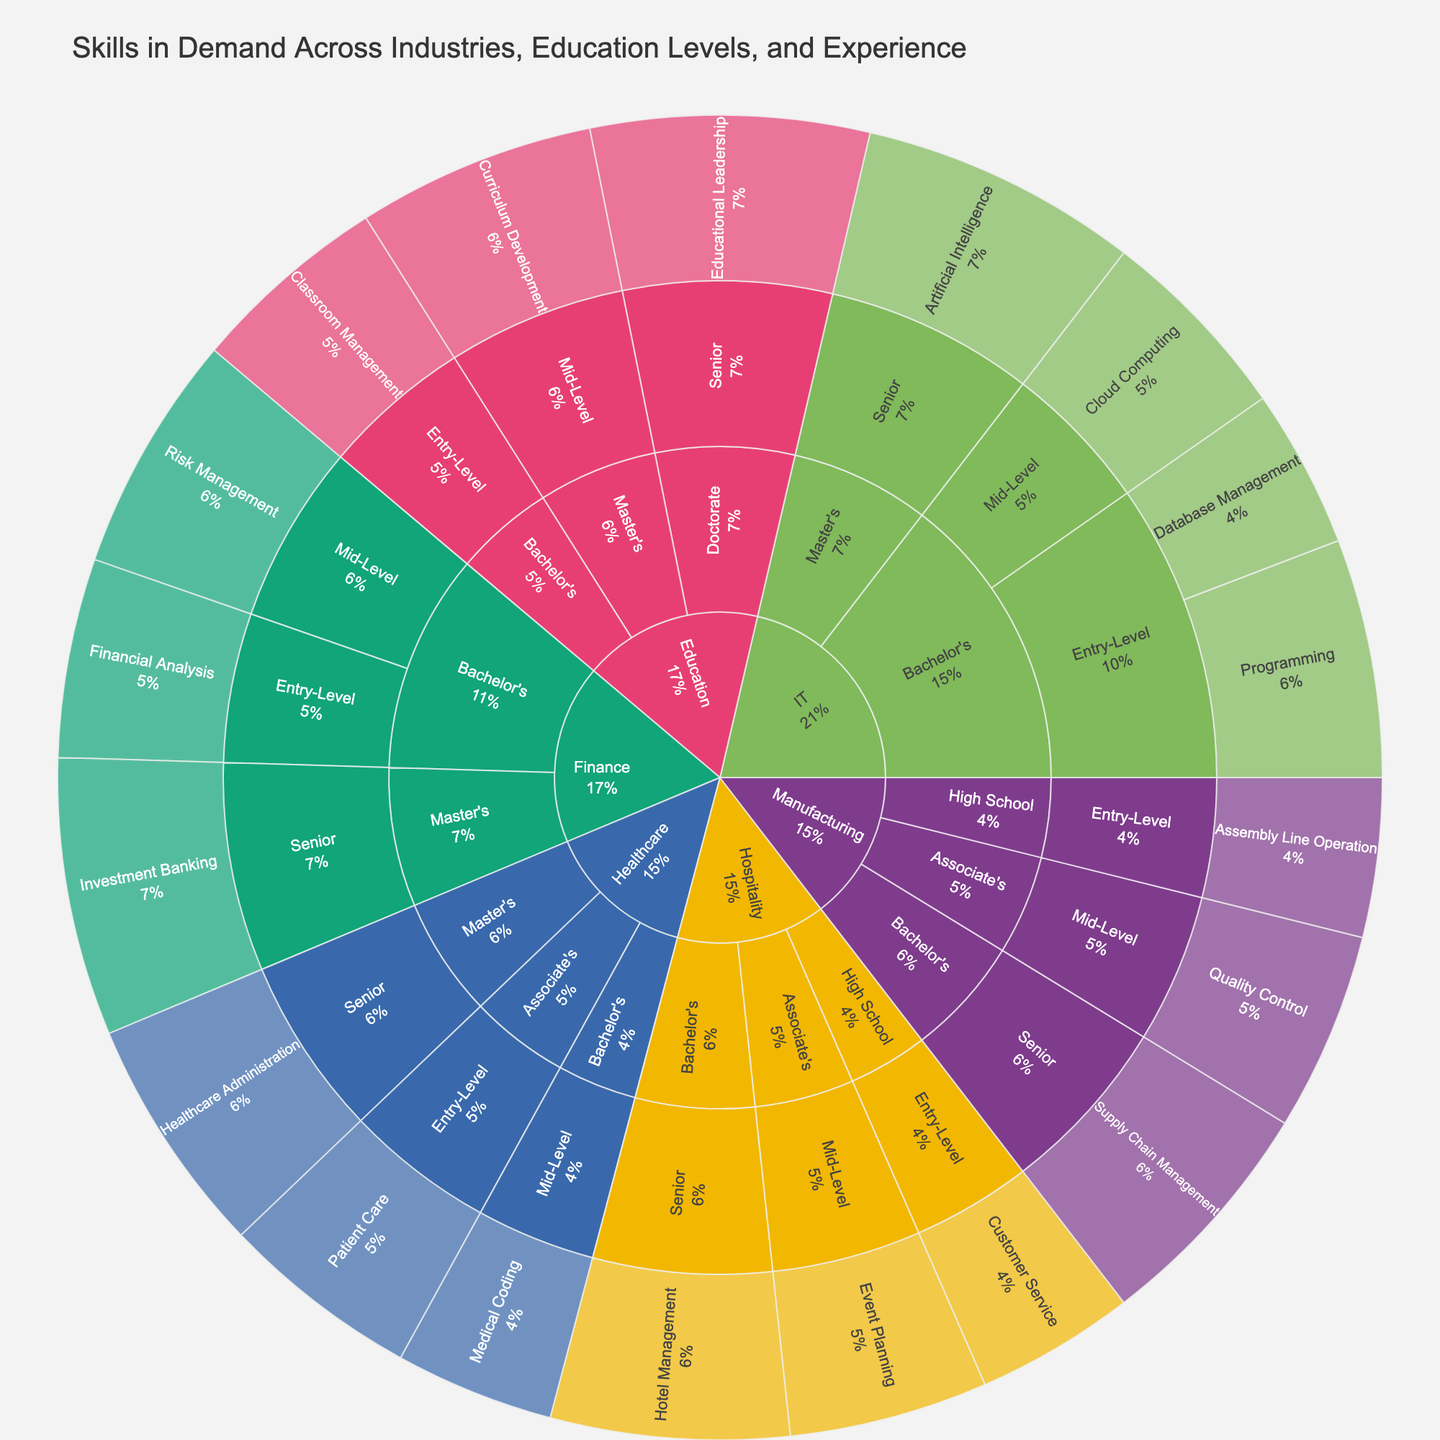What's the title of the figure? The title is typically displayed at the top of the figure, providing a summary of what the figure represents. In this case, the title "Skills in Demand Across Industries, Education Levels, and Experience" clearly indicates that the plot is about the varying demand for skills across different industries, education levels, and experience levels.
Answer: Skills in Demand Across Industries, Education Levels, and Experience Which skill has the highest demand in the IT industry for Senior-level professionals with a Master’s degree? To determine this, follow the hierarchical structure starting from the IT industry, then drill down to Master's education, and further to Senior experience. The skill with the largest section under this branch is "Artificial Intelligence" with a value of 35.
Answer: Artificial Intelligence What's the total demand value for skills in the Hospitality industry? Sum up the values for all the skills represented in the Hospitality branch of the Sunburst Plot. These are Customer Service (20), Event Planning (25), and Hotel Management (30). Thus, the total demand value is 20 + 25 + 30 = 75.
Answer: 75 Compare the demand for Financial Analysis in the Finance industry with Classroom Management in the Education industry. Which one is higher and by how much? Navigate to the respective branches and find the demand values. Financial Analysis in Finance for Bachelor's entry-level is 25, and Classroom Management in Education for Bachelor's entry-level is also 25. Compare these values, and they are equal, so the difference is 0.
Answer: They are equal, difference is 0 Which education level in the Manufacturing industry has the highest demand for skills, and what is the total value? Navigate through the Manufacturing branch and compare the demand values for High School, Associate's, and Bachelor's levels. Entry-Level (High School) has 20, Mid-Level (Associate's) has 25, and Senior (Bachelor's) has 30. Therefore, Bachelor's has the highest demand. The total for Bachelor's education level is 30.
Answer: Bachelor's with a value of 30 In the Healthcare industry, what is the demand value for skills at both the Entry-Level and Mid-Level combined? For Entry-Level (Associate's), the demand value is 25 for Patient Care, and for Mid-Level (Bachelor's), the demand value is 20 for Medical Coding. Combine these values: 25 + 20 = 45.
Answer: 45 How does the demand for Event Planning in the Hospitality industry compare to Supply Chain Management in the Manufacturing industry? Check the respective branches for the demand values: Event Planning (Mid-Level, Associate's) in Hospitality is 25, and Supply Chain Management (Senior, Bachelor's) in Manufacturing is 30. Supply Chain Management has a higher value.
Answer: Supply Chain Management is higher by 5 What's the average demand value for all Mid-Level skills across all industries? Identify all Mid-Level demand values and calculate their average. The values are: Cloud Computing (25), Medical Coding (20), Quality Control (25), Risk Management (30), Event Planning (25), Curriculum Development (30). Sum these values: 25 + 20 + 25 + 30 + 25 + 30 = 155. The number of data points is 6, so the average is 155 / 6 ≈ 25.83.
Answer: Approximately 25.83 Which skill has the lowest demand value in the IT industry? Check all skills within the IT industry branch and compare their demand values: Programming (30), Database Management (20), Cloud Computing (25), and Artificial Intelligence (35). The lowest demand value is for Database Management with a value of 20.
Answer: Database Management 